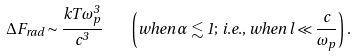<formula> <loc_0><loc_0><loc_500><loc_500>\Delta F _ { r a d } \sim \frac { k T \omega ^ { 3 } _ { p } } { c ^ { 3 } } \quad \left ( { w h e n } \, \alpha \lesssim 1 ; \, { i . e . , \, w h e n } \, l \ll \frac { c } { \omega _ { p } } \right ) .</formula> 